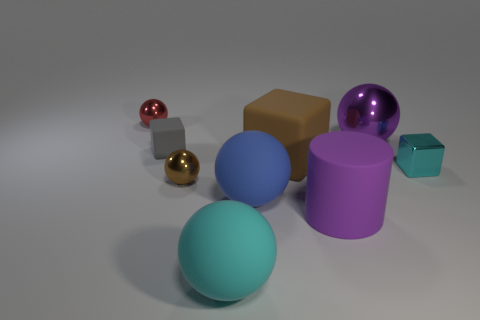Subtract 1 spheres. How many spheres are left? 4 Subtract all brown spheres. How many spheres are left? 4 Subtract all purple shiny spheres. How many spheres are left? 4 Add 1 tiny gray objects. How many objects exist? 10 Subtract all purple balls. Subtract all gray cylinders. How many balls are left? 4 Subtract all cubes. How many objects are left? 6 Add 1 tiny red shiny balls. How many tiny red shiny balls exist? 2 Subtract 1 blue balls. How many objects are left? 8 Subtract all big blue rubber blocks. Subtract all small gray matte things. How many objects are left? 8 Add 2 big brown cubes. How many big brown cubes are left? 3 